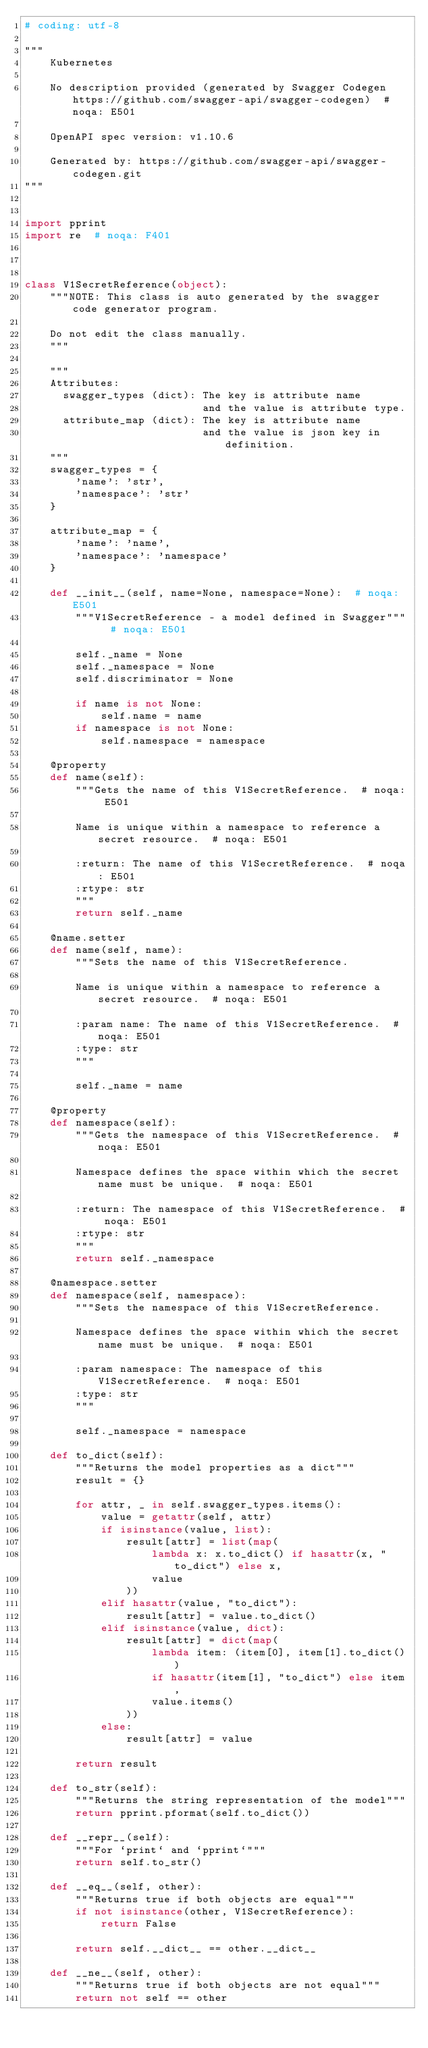<code> <loc_0><loc_0><loc_500><loc_500><_Python_># coding: utf-8

"""
    Kubernetes

    No description provided (generated by Swagger Codegen https://github.com/swagger-api/swagger-codegen)  # noqa: E501

    OpenAPI spec version: v1.10.6
    
    Generated by: https://github.com/swagger-api/swagger-codegen.git
"""


import pprint
import re  # noqa: F401



class V1SecretReference(object):
    """NOTE: This class is auto generated by the swagger code generator program.

    Do not edit the class manually.
    """

    """
    Attributes:
      swagger_types (dict): The key is attribute name
                            and the value is attribute type.
      attribute_map (dict): The key is attribute name
                            and the value is json key in definition.
    """
    swagger_types = {
        'name': 'str',
        'namespace': 'str'
    }

    attribute_map = {
        'name': 'name',
        'namespace': 'namespace'
    }

    def __init__(self, name=None, namespace=None):  # noqa: E501
        """V1SecretReference - a model defined in Swagger"""  # noqa: E501

        self._name = None
        self._namespace = None
        self.discriminator = None

        if name is not None:
            self.name = name
        if namespace is not None:
            self.namespace = namespace

    @property
    def name(self):
        """Gets the name of this V1SecretReference.  # noqa: E501

        Name is unique within a namespace to reference a secret resource.  # noqa: E501

        :return: The name of this V1SecretReference.  # noqa: E501
        :rtype: str
        """
        return self._name

    @name.setter
    def name(self, name):
        """Sets the name of this V1SecretReference.

        Name is unique within a namespace to reference a secret resource.  # noqa: E501

        :param name: The name of this V1SecretReference.  # noqa: E501
        :type: str
        """

        self._name = name

    @property
    def namespace(self):
        """Gets the namespace of this V1SecretReference.  # noqa: E501

        Namespace defines the space within which the secret name must be unique.  # noqa: E501

        :return: The namespace of this V1SecretReference.  # noqa: E501
        :rtype: str
        """
        return self._namespace

    @namespace.setter
    def namespace(self, namespace):
        """Sets the namespace of this V1SecretReference.

        Namespace defines the space within which the secret name must be unique.  # noqa: E501

        :param namespace: The namespace of this V1SecretReference.  # noqa: E501
        :type: str
        """

        self._namespace = namespace

    def to_dict(self):
        """Returns the model properties as a dict"""
        result = {}

        for attr, _ in self.swagger_types.items():
            value = getattr(self, attr)
            if isinstance(value, list):
                result[attr] = list(map(
                    lambda x: x.to_dict() if hasattr(x, "to_dict") else x,
                    value
                ))
            elif hasattr(value, "to_dict"):
                result[attr] = value.to_dict()
            elif isinstance(value, dict):
                result[attr] = dict(map(
                    lambda item: (item[0], item[1].to_dict())
                    if hasattr(item[1], "to_dict") else item,
                    value.items()
                ))
            else:
                result[attr] = value

        return result

    def to_str(self):
        """Returns the string representation of the model"""
        return pprint.pformat(self.to_dict())

    def __repr__(self):
        """For `print` and `pprint`"""
        return self.to_str()

    def __eq__(self, other):
        """Returns true if both objects are equal"""
        if not isinstance(other, V1SecretReference):
            return False

        return self.__dict__ == other.__dict__

    def __ne__(self, other):
        """Returns true if both objects are not equal"""
        return not self == other
</code> 